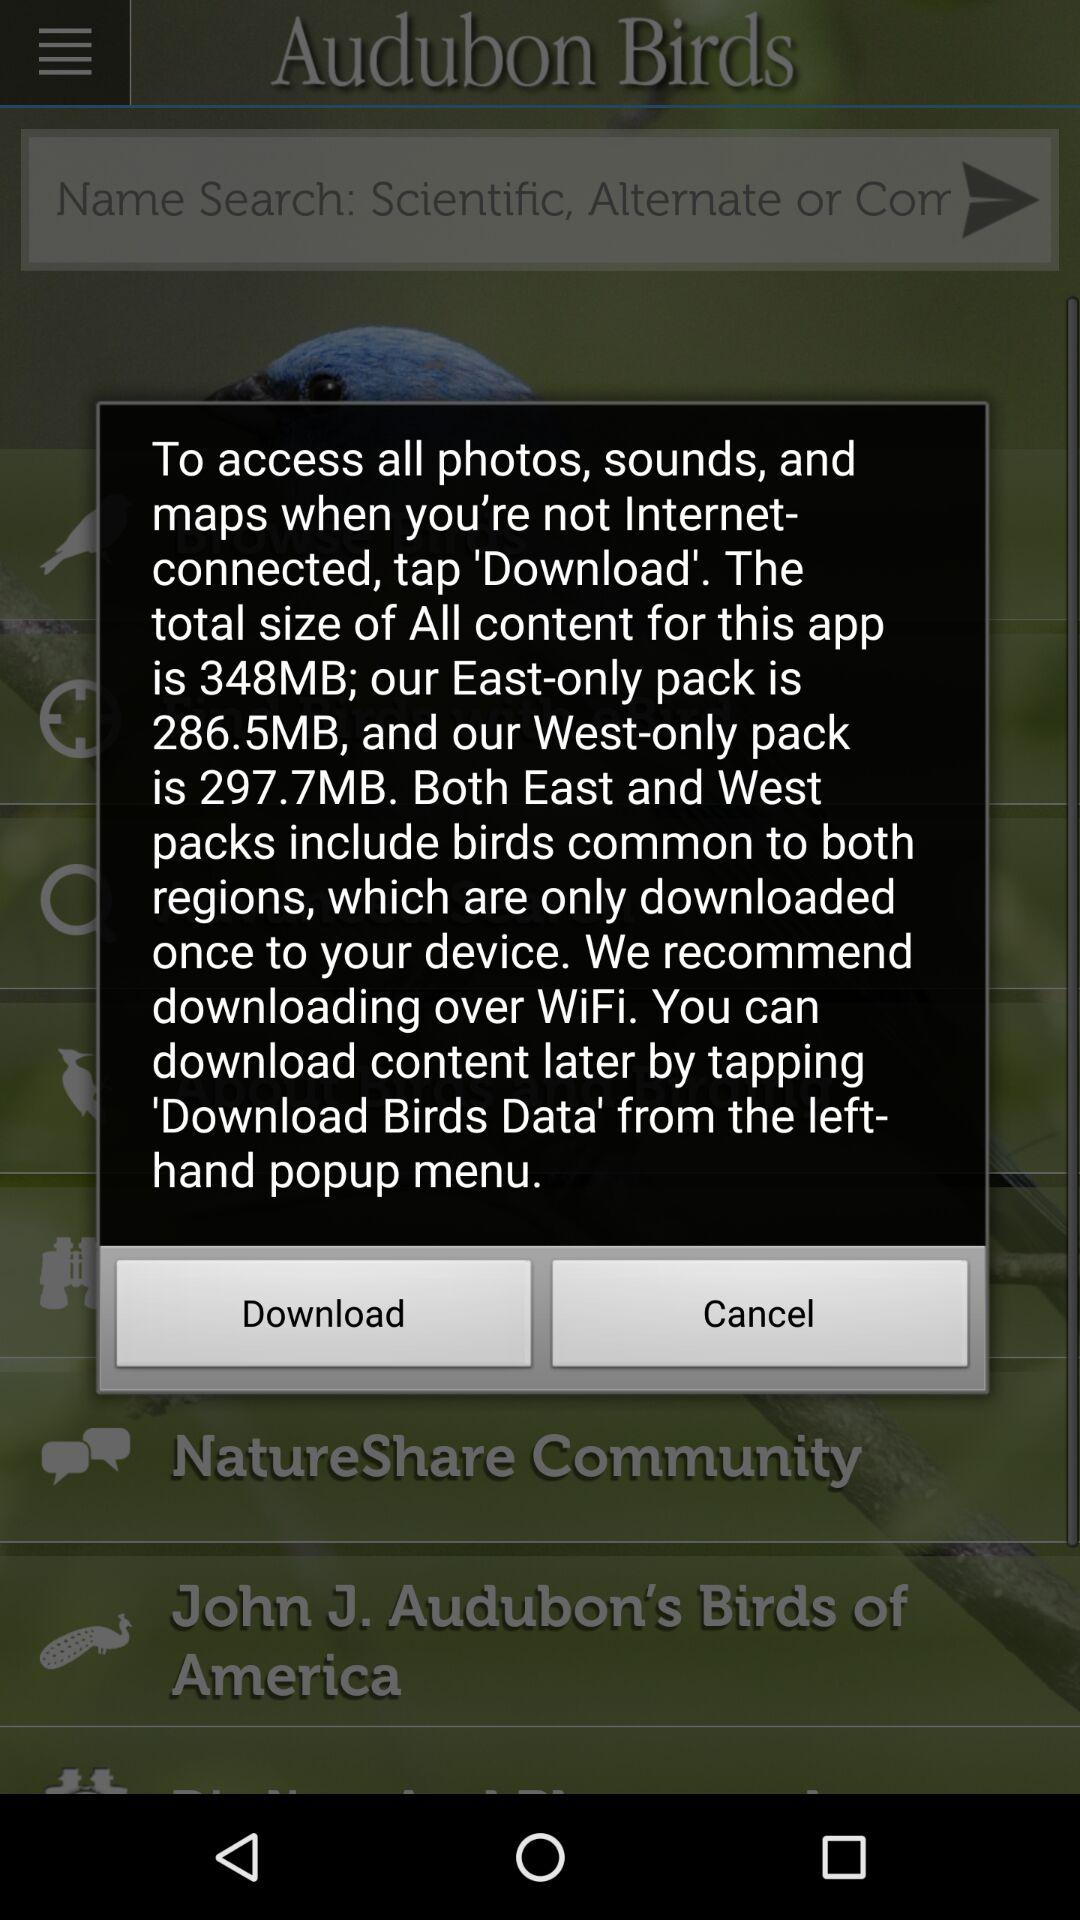How much data is required to download all of the content for this app?
Answer the question using a single word or phrase. 348MB 